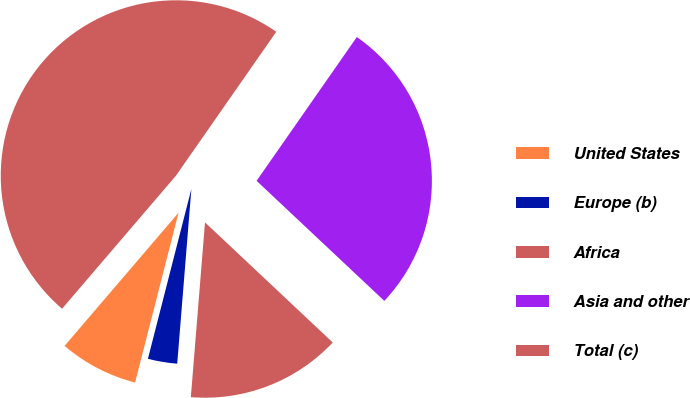Convert chart to OTSL. <chart><loc_0><loc_0><loc_500><loc_500><pie_chart><fcel>United States<fcel>Europe (b)<fcel>Africa<fcel>Asia and other<fcel>Total (c)<nl><fcel>7.28%<fcel>2.7%<fcel>14.28%<fcel>27.32%<fcel>48.42%<nl></chart> 